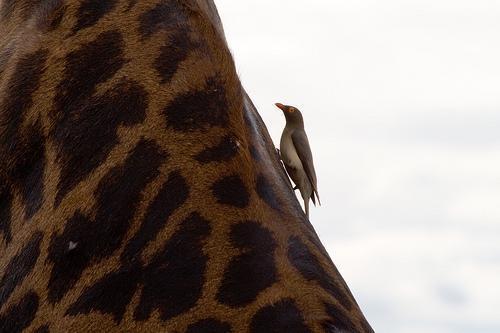How many birds are in the picture?
Give a very brief answer. 1. 